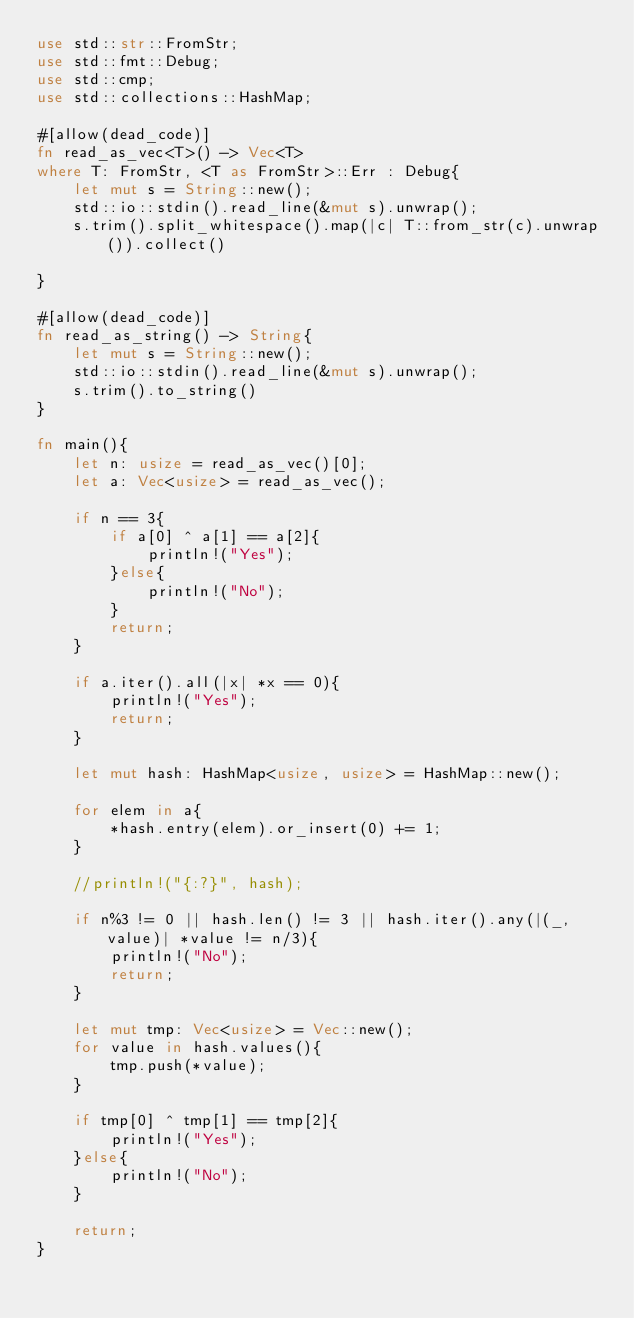Convert code to text. <code><loc_0><loc_0><loc_500><loc_500><_Rust_>use std::str::FromStr;
use std::fmt::Debug;
use std::cmp;
use std::collections::HashMap;

#[allow(dead_code)]
fn read_as_vec<T>() -> Vec<T>
where T: FromStr, <T as FromStr>::Err : Debug{
    let mut s = String::new();
    std::io::stdin().read_line(&mut s).unwrap();
    s.trim().split_whitespace().map(|c| T::from_str(c).unwrap()).collect()

}

#[allow(dead_code)]
fn read_as_string() -> String{
    let mut s = String::new();
    std::io::stdin().read_line(&mut s).unwrap();
    s.trim().to_string()
}

fn main(){
    let n: usize = read_as_vec()[0];
    let a: Vec<usize> = read_as_vec();

    if n == 3{
        if a[0] ^ a[1] == a[2]{
            println!("Yes");
        }else{
            println!("No");            
        }
        return;
    }

    if a.iter().all(|x| *x == 0){
        println!("Yes");
        return;
    }

    let mut hash: HashMap<usize, usize> = HashMap::new();

    for elem in a{
        *hash.entry(elem).or_insert(0) += 1;
    }

    //println!("{:?}", hash);

    if n%3 != 0 || hash.len() != 3 || hash.iter().any(|(_, value)| *value != n/3){
        println!("No");
        return;
    }

    let mut tmp: Vec<usize> = Vec::new();
    for value in hash.values(){
        tmp.push(*value);
    }

    if tmp[0] ^ tmp[1] == tmp[2]{
        println!("Yes");
    }else{
        println!("No");
    }
    
    return;        
}
</code> 